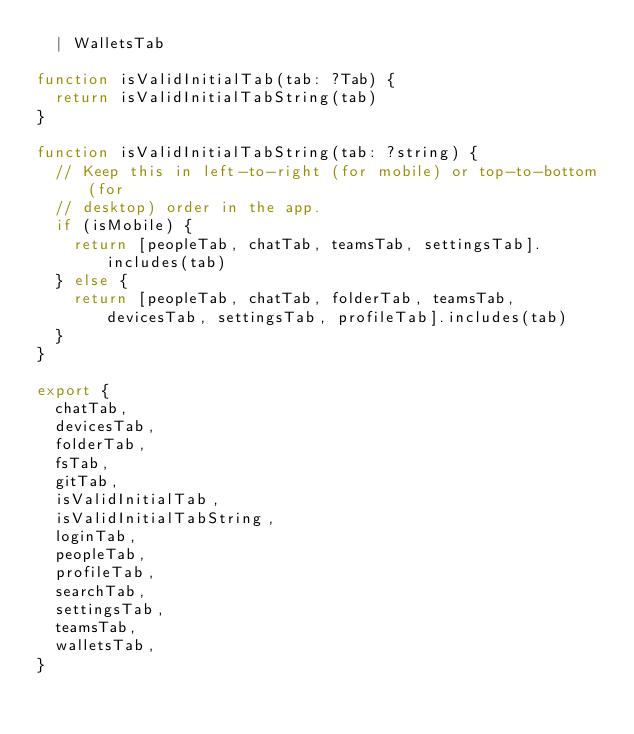Convert code to text. <code><loc_0><loc_0><loc_500><loc_500><_JavaScript_>  | WalletsTab

function isValidInitialTab(tab: ?Tab) {
  return isValidInitialTabString(tab)
}

function isValidInitialTabString(tab: ?string) {
  // Keep this in left-to-right (for mobile) or top-to-bottom (for
  // desktop) order in the app.
  if (isMobile) {
    return [peopleTab, chatTab, teamsTab, settingsTab].includes(tab)
  } else {
    return [peopleTab, chatTab, folderTab, teamsTab, devicesTab, settingsTab, profileTab].includes(tab)
  }
}

export {
  chatTab,
  devicesTab,
  folderTab,
  fsTab,
  gitTab,
  isValidInitialTab,
  isValidInitialTabString,
  loginTab,
  peopleTab,
  profileTab,
  searchTab,
  settingsTab,
  teamsTab,
  walletsTab,
}
</code> 